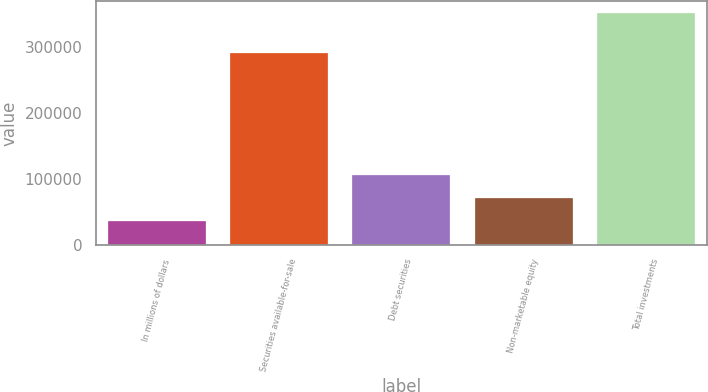<chart> <loc_0><loc_0><loc_500><loc_500><bar_chart><fcel>In millions of dollars<fcel>Securities available-for-sale<fcel>Debt securities<fcel>Non-marketable equity<fcel>Total investments<nl><fcel>36314.4<fcel>290914<fcel>106531<fcel>71422.8<fcel>352290<nl></chart> 